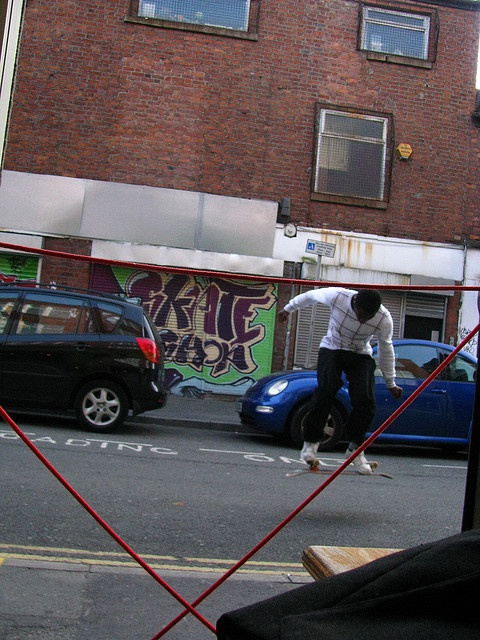Describe the objects in this image and their specific colors. I can see car in black, gray, navy, and blue tones, car in black, navy, gray, and blue tones, people in black, gray, darkgray, and lavender tones, and skateboard in black, gray, and maroon tones in this image. 